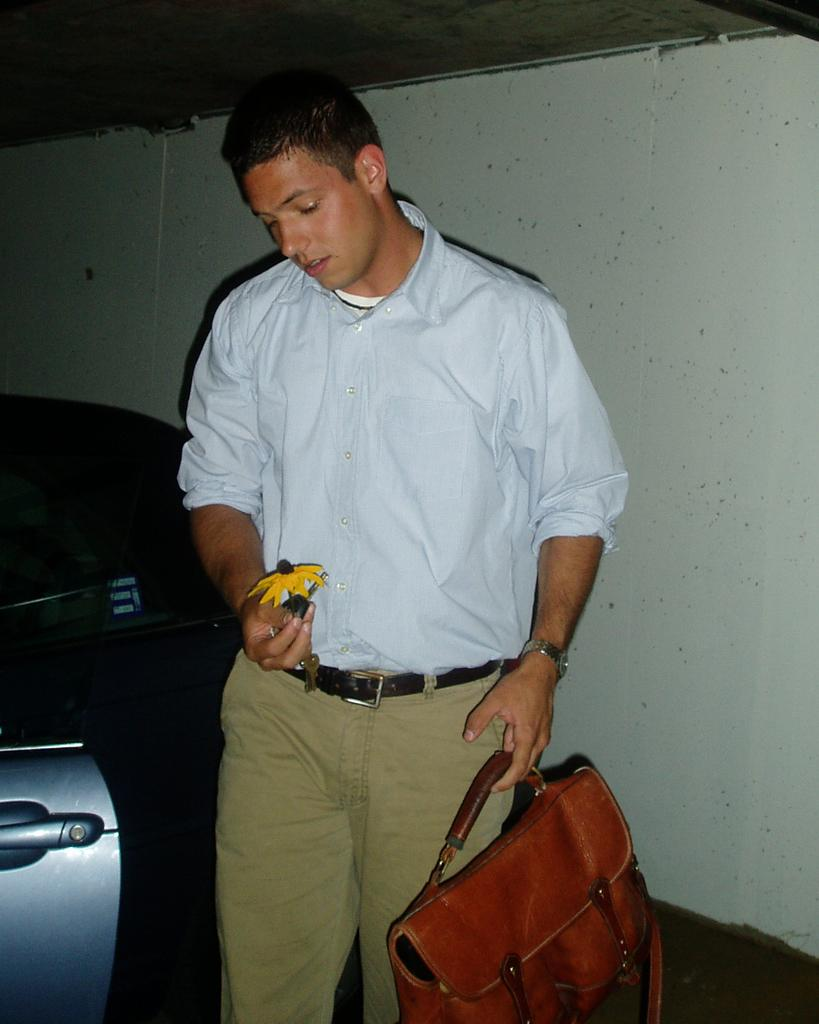What color is the shirt the person is wearing in the image? The person is wearing a blue shirt. What is the person holding in his left hand? The person is holding a bag in his left hand. What is the person holding in his right hand? The person is holding a flower in his right hand. What type of vehicle is beside the person? There is a blue car beside the person. What substance is the person consuming in the image? There is no substance being consumed in the image; the person is holding a bag and a flower. 